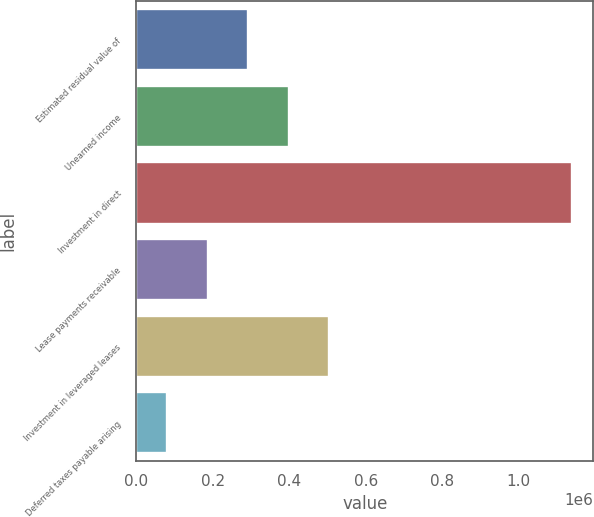Convert chart to OTSL. <chart><loc_0><loc_0><loc_500><loc_500><bar_chart><fcel>Estimated residual value of<fcel>Unearned income<fcel>Investment in direct<fcel>Lease payments receivable<fcel>Investment in leveraged leases<fcel>Deferred taxes payable arising<nl><fcel>292885<fcel>398648<fcel>1.13899e+06<fcel>187122<fcel>504411<fcel>81359<nl></chart> 